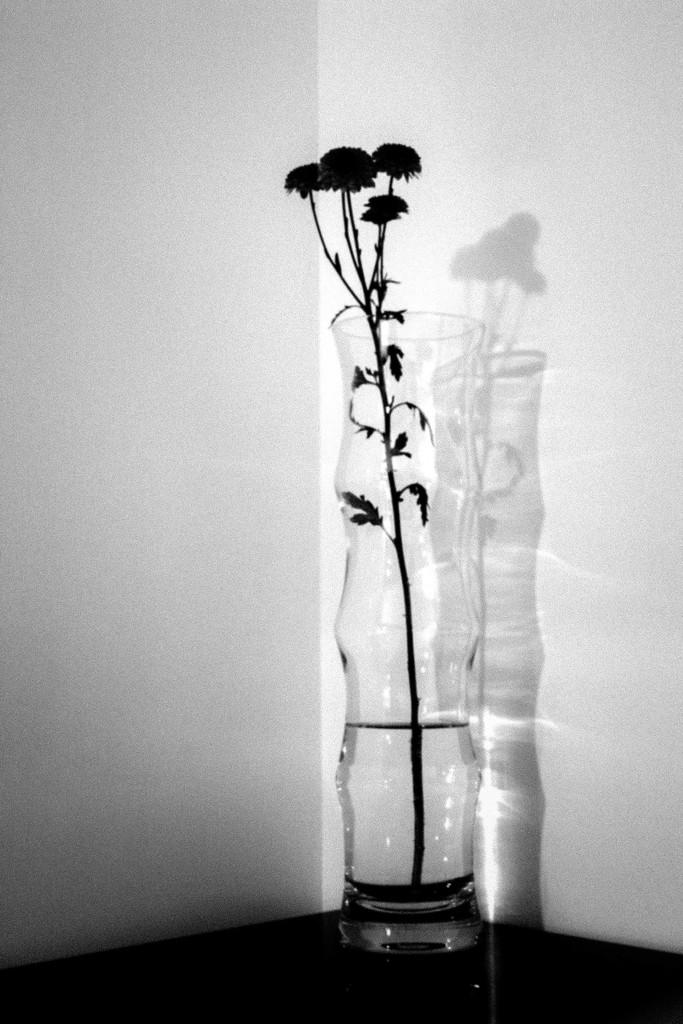What object is the main focus of the image? There is a flower vase in the image. What can be seen in the background of the image? There is a wall in the background of the image. What is the color scheme of the image? The image is black and white. What direction is the mom running in the image? There is no mom or running depicted in the image; it only features a flower vase and a wall in the background. 